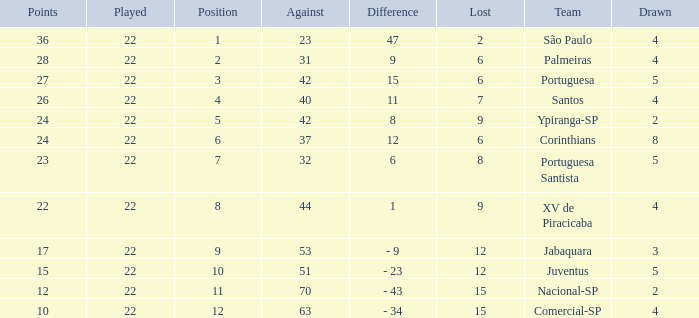Could you help me parse every detail presented in this table? {'header': ['Points', 'Played', 'Position', 'Against', 'Difference', 'Lost', 'Team', 'Drawn'], 'rows': [['36', '22', '1', '23', '47', '2', 'São Paulo', '4'], ['28', '22', '2', '31', '9', '6', 'Palmeiras', '4'], ['27', '22', '3', '42', '15', '6', 'Portuguesa', '5'], ['26', '22', '4', '40', '11', '7', 'Santos', '4'], ['24', '22', '5', '42', '8', '9', 'Ypiranga-SP', '2'], ['24', '22', '6', '37', '12', '6', 'Corinthians', '8'], ['23', '22', '7', '32', '6', '8', 'Portuguesa Santista', '5'], ['22', '22', '8', '44', '1', '9', 'XV de Piracicaba', '4'], ['17', '22', '9', '53', '- 9', '12', 'Jabaquara', '3'], ['15', '22', '10', '51', '- 23', '12', 'Juventus', '5'], ['12', '22', '11', '70', '- 43', '15', 'Nacional-SP', '2'], ['10', '22', '12', '63', '- 34', '15', 'Comercial-SP', '4']]} Which Against has a Drawn smaller than 5, and a Lost smaller than 6, and a Points larger than 36? 0.0. 